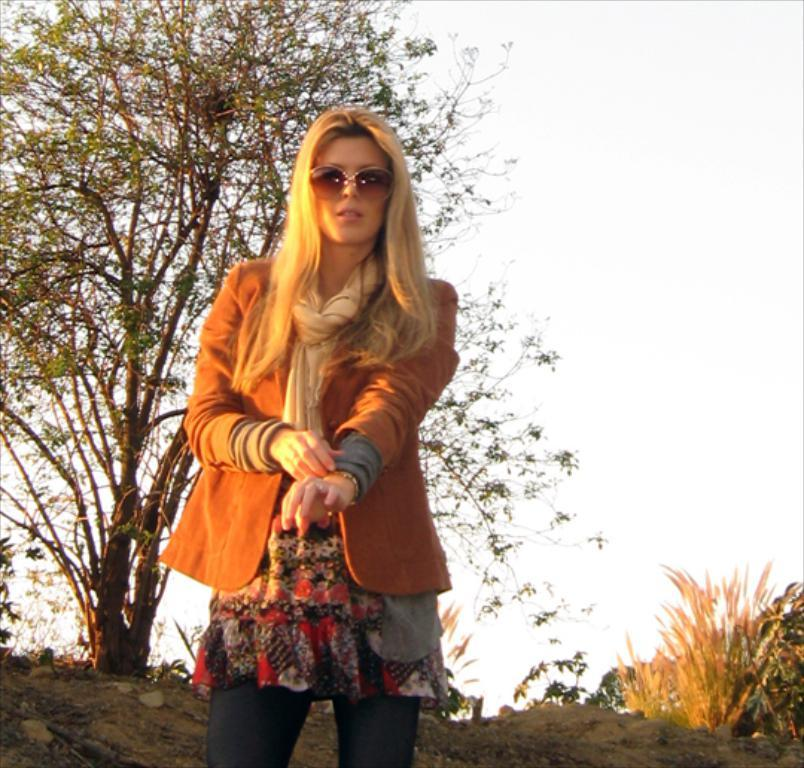Who is present in the image? There is a woman in the image. Where is the woman located in the image? The woman is at the bottom of the image. What type of vegetation can be seen in the image? There is a tree and plants in the image. What can be seen in the background of the image? The sky is visible in the background of the image. What is the woman's annual income in the image? There is no information about the woman's income in the image. Can you tell me how many dogs are present in the image? There are no dogs present in the image. 